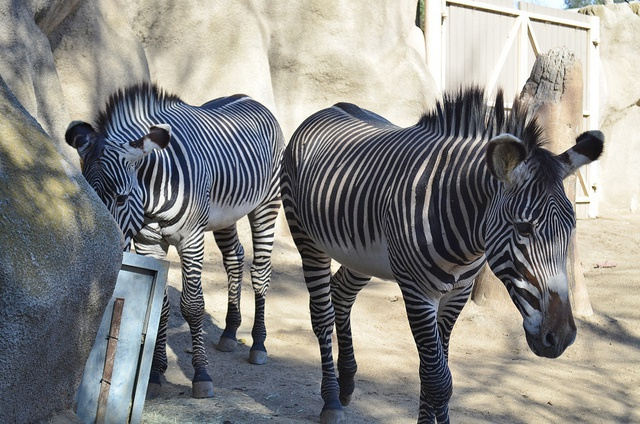Describe the objects in this image and their specific colors. I can see zebra in darkgray, black, and gray tones and zebra in darkgray, black, gray, and navy tones in this image. 